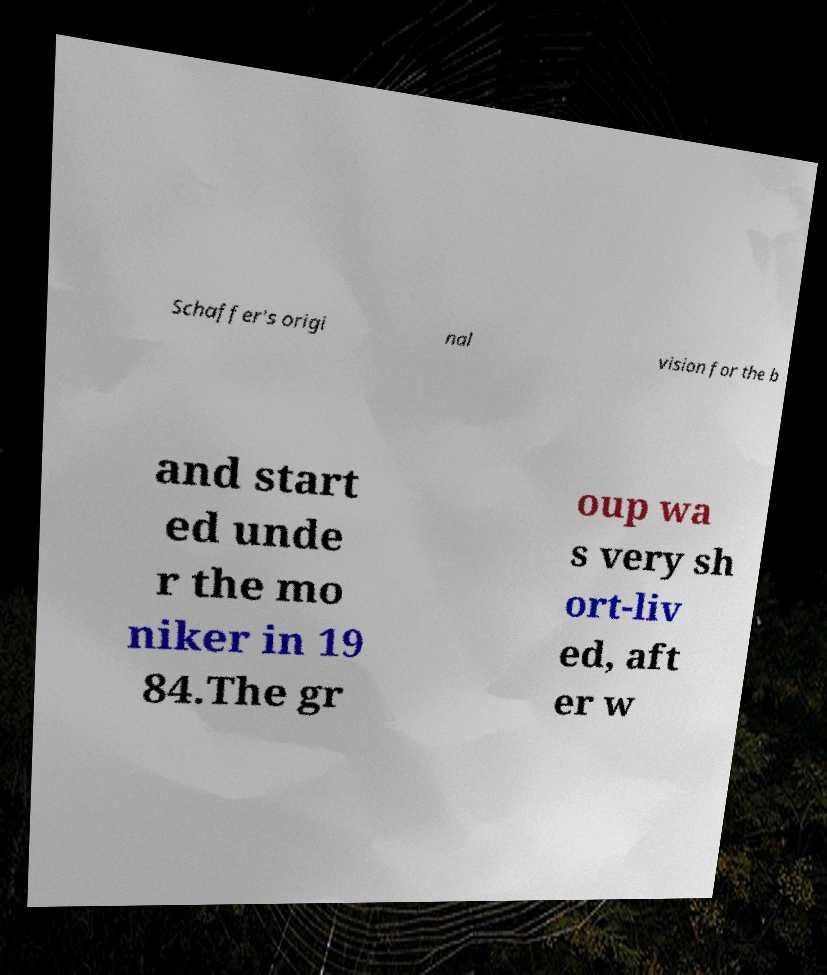I need the written content from this picture converted into text. Can you do that? Schaffer's origi nal vision for the b and start ed unde r the mo niker in 19 84.The gr oup wa s very sh ort-liv ed, aft er w 